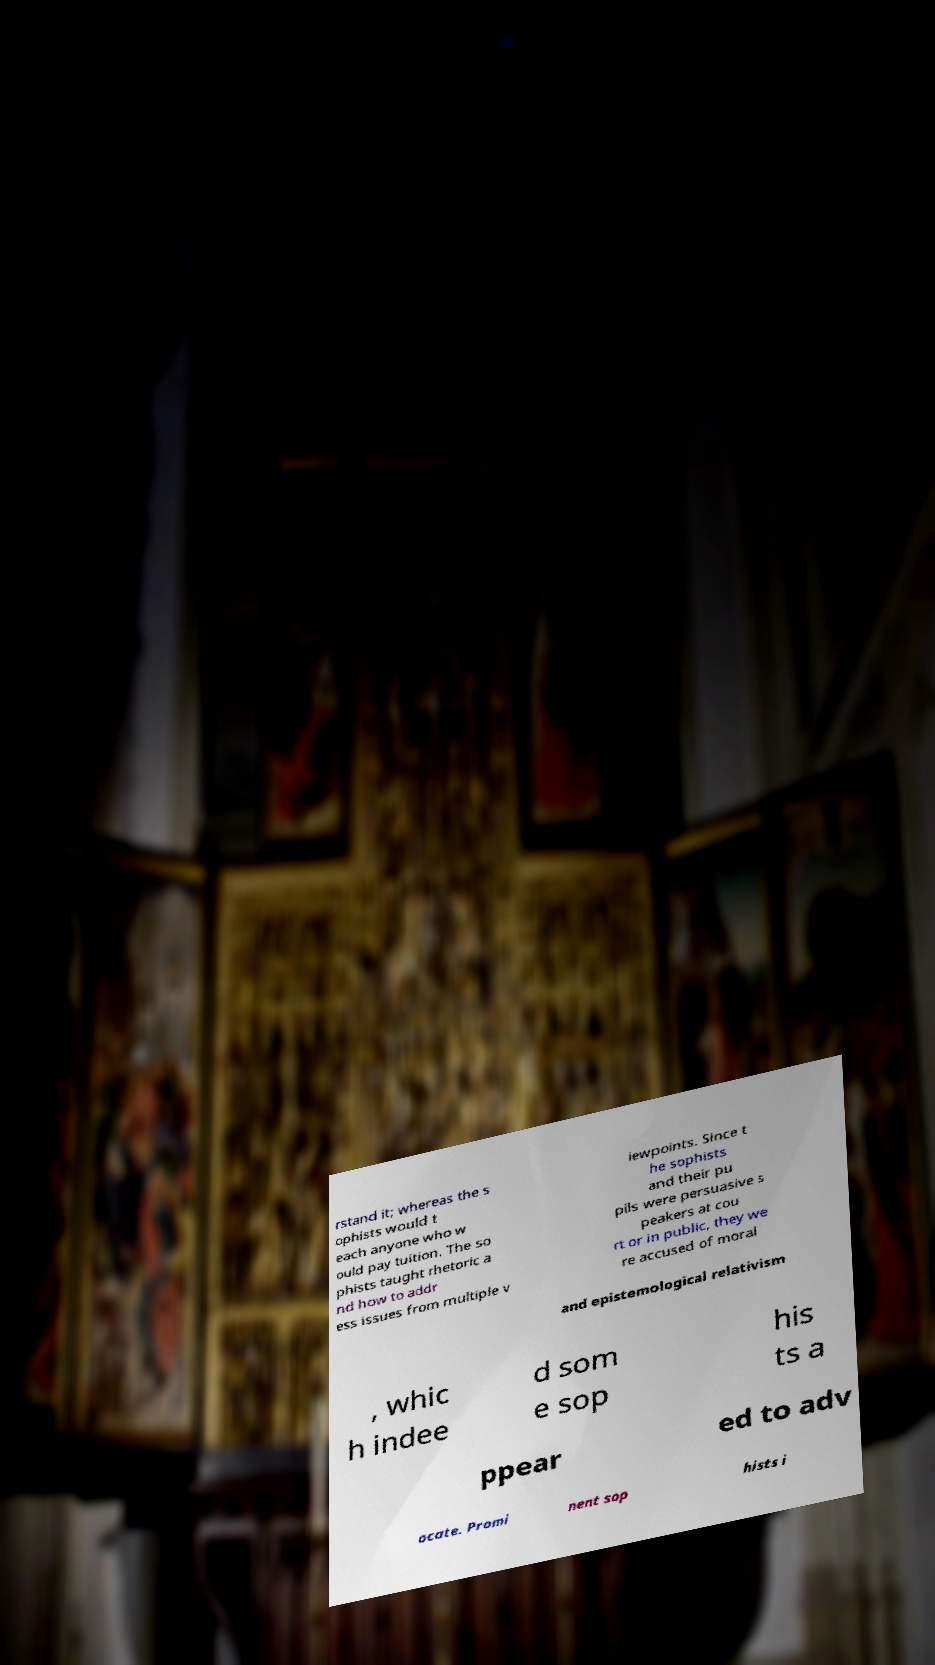Can you accurately transcribe the text from the provided image for me? rstand it; whereas the s ophists would t each anyone who w ould pay tuition. The so phists taught rhetoric a nd how to addr ess issues from multiple v iewpoints. Since t he sophists and their pu pils were persuasive s peakers at cou rt or in public, they we re accused of moral and epistemological relativism , whic h indee d som e sop his ts a ppear ed to adv ocate. Promi nent sop hists i 